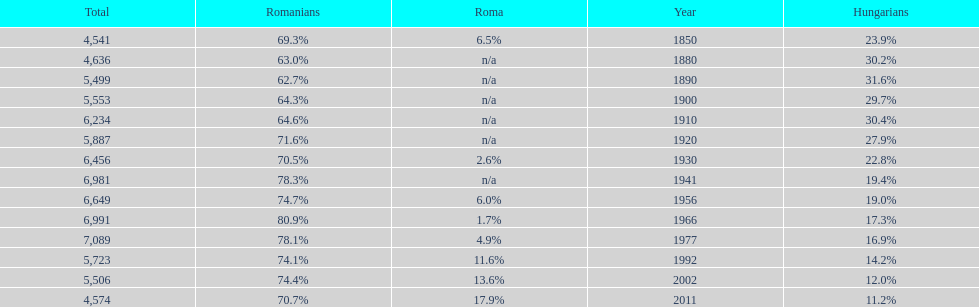In what year was the maximum percentage of hungarians recorded? 1890. 